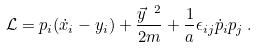Convert formula to latex. <formula><loc_0><loc_0><loc_500><loc_500>\mathcal { L } = p _ { i } ( \dot { x } _ { i } - y _ { i } ) + \frac { \vec { y } ^ { \ 2 } } { 2 m } + \frac { 1 } { a } \epsilon _ { i j } \dot { p } _ { i } p _ { j } \, .</formula> 